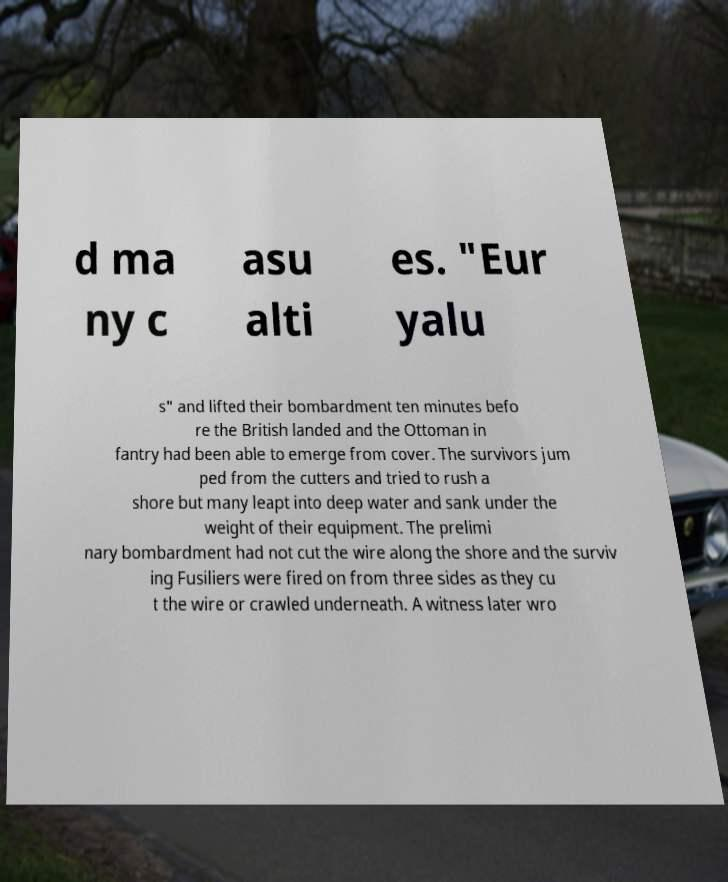What messages or text are displayed in this image? I need them in a readable, typed format. d ma ny c asu alti es. "Eur yalu s" and lifted their bombardment ten minutes befo re the British landed and the Ottoman in fantry had been able to emerge from cover. The survivors jum ped from the cutters and tried to rush a shore but many leapt into deep water and sank under the weight of their equipment. The prelimi nary bombardment had not cut the wire along the shore and the surviv ing Fusiliers were fired on from three sides as they cu t the wire or crawled underneath. A witness later wro 